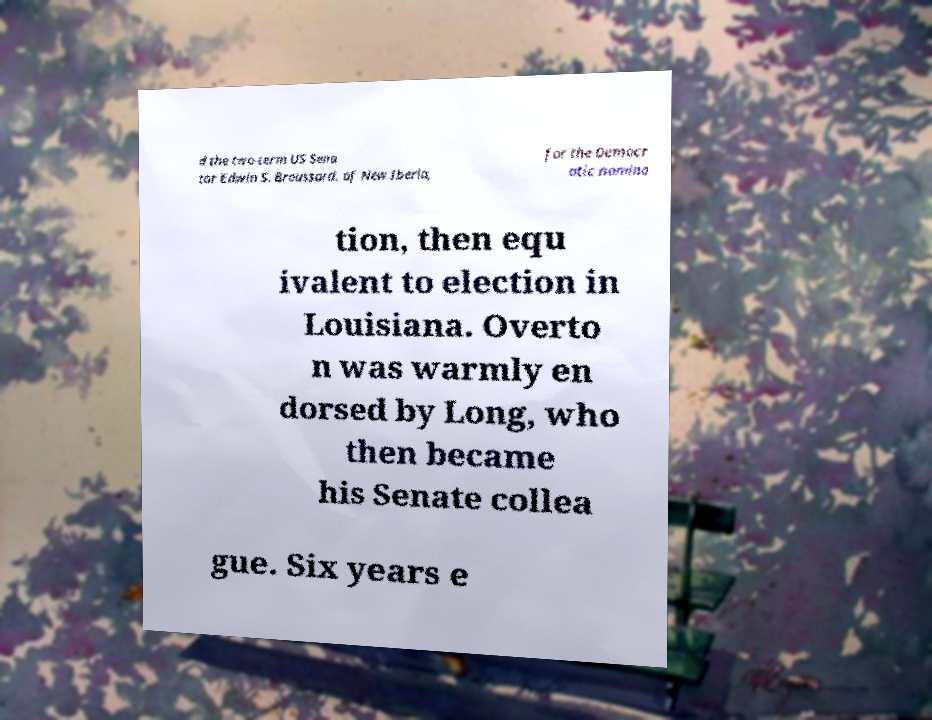Please read and relay the text visible in this image. What does it say? d the two-term US Sena tor Edwin S. Broussard, of New Iberia, for the Democr atic nomina tion, then equ ivalent to election in Louisiana. Overto n was warmly en dorsed by Long, who then became his Senate collea gue. Six years e 